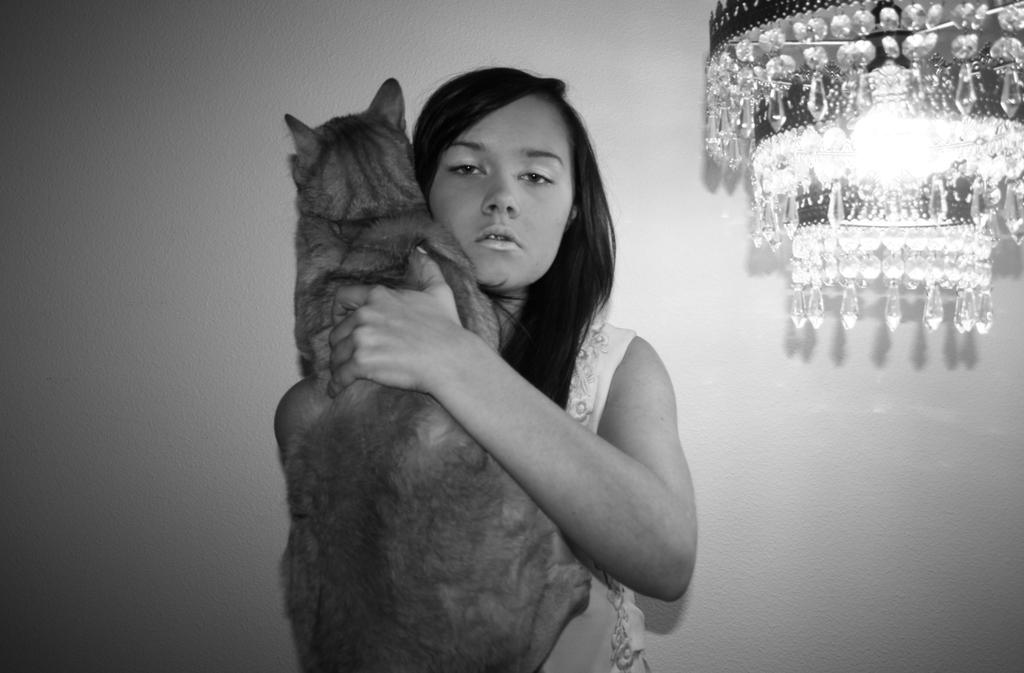What is the color scheme of the image? The image is black and white. Can you describe the main subject in the image? There is a lady in the image. What is the lady holding in the image? The lady is holding an animal. What can be seen in the background of the image? There is a wall visible in the image. Where are the lights located in the image? The lights are on the right side of the image. What type of clover is growing on the lady's nose in the image? There is no clover present in the image, and the lady's nose is not mentioned in the provided facts. 